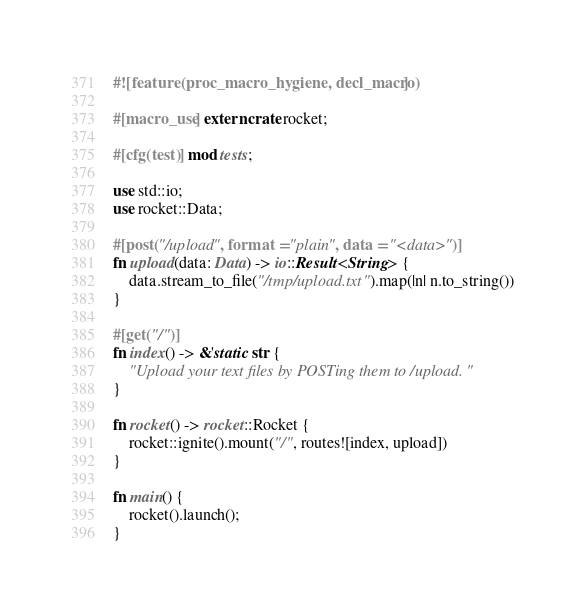<code> <loc_0><loc_0><loc_500><loc_500><_Rust_>#![feature(proc_macro_hygiene, decl_macro)]

#[macro_use] extern crate rocket;

#[cfg(test)] mod tests;

use std::io;
use rocket::Data;

#[post("/upload", format = "plain", data = "<data>")]
fn upload(data: Data) -> io::Result<String> {
    data.stream_to_file("/tmp/upload.txt").map(|n| n.to_string())
}

#[get("/")]
fn index() -> &'static str {
    "Upload your text files by POSTing them to /upload."
}

fn rocket() -> rocket::Rocket {
    rocket::ignite().mount("/", routes![index, upload])
}

fn main() {
    rocket().launch();
}
</code> 